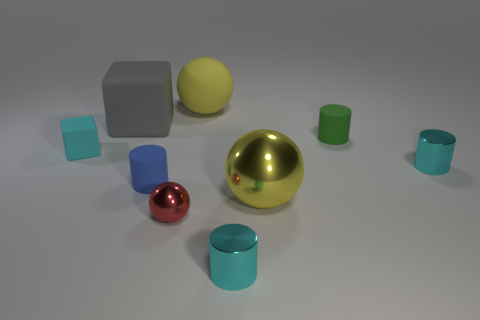There is a yellow object that is in front of the small object behind the cyan thing on the left side of the small blue rubber cylinder; what shape is it? The yellow object you're referring to is indeed a sphere. It's positioned in front of a small grey cube and behind a cyan colored cylinder, while to the left of a smaller blue cylinder. The geometry in the scene presents a variety of shapes, and the yellow sphere stands out due to its vibrant color and reflective surface. 